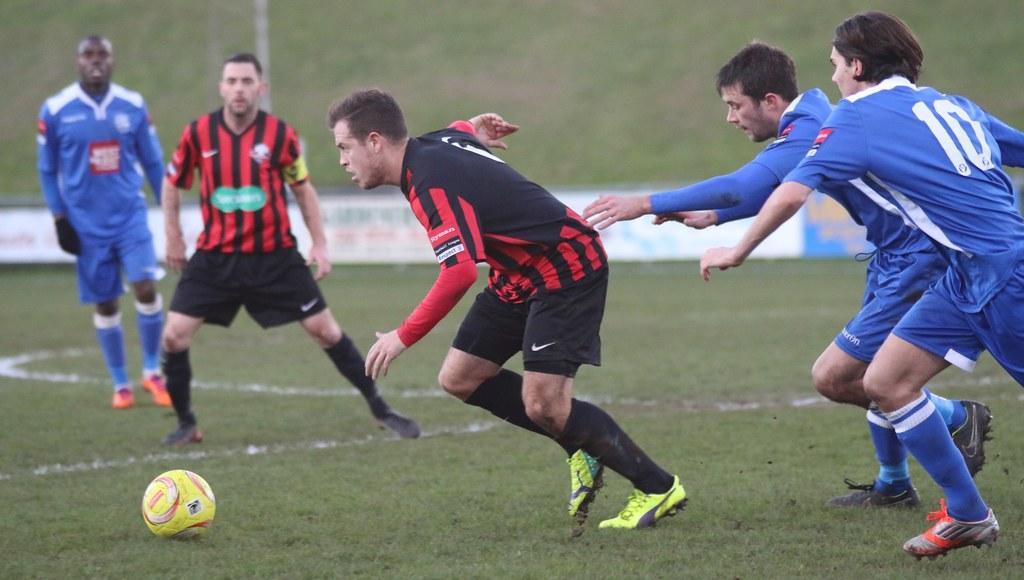Describe this image in one or two sentences. In this image we can see few people playing soccer. There is a grassy ground in the image. There are few advertising boards in the image. 